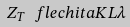Convert formula to latex. <formula><loc_0><loc_0><loc_500><loc_500>Z _ { T } { \ f l e c h i t a } K L \lambda</formula> 